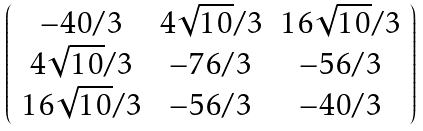<formula> <loc_0><loc_0><loc_500><loc_500>\left ( \begin{array} { c c c } - 4 0 / 3 & 4 \sqrt { 1 0 } / 3 & 1 6 \sqrt { 1 0 } / 3 \\ 4 \sqrt { 1 0 } / 3 & - 7 6 / 3 & - 5 6 / 3 \\ 1 6 \sqrt { 1 0 } / 3 & - 5 6 / 3 & - 4 0 / 3 \end{array} \right )</formula> 